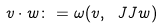<formula> <loc_0><loc_0><loc_500><loc_500>v \cdot w \colon = \omega ( v , \ J J w )</formula> 